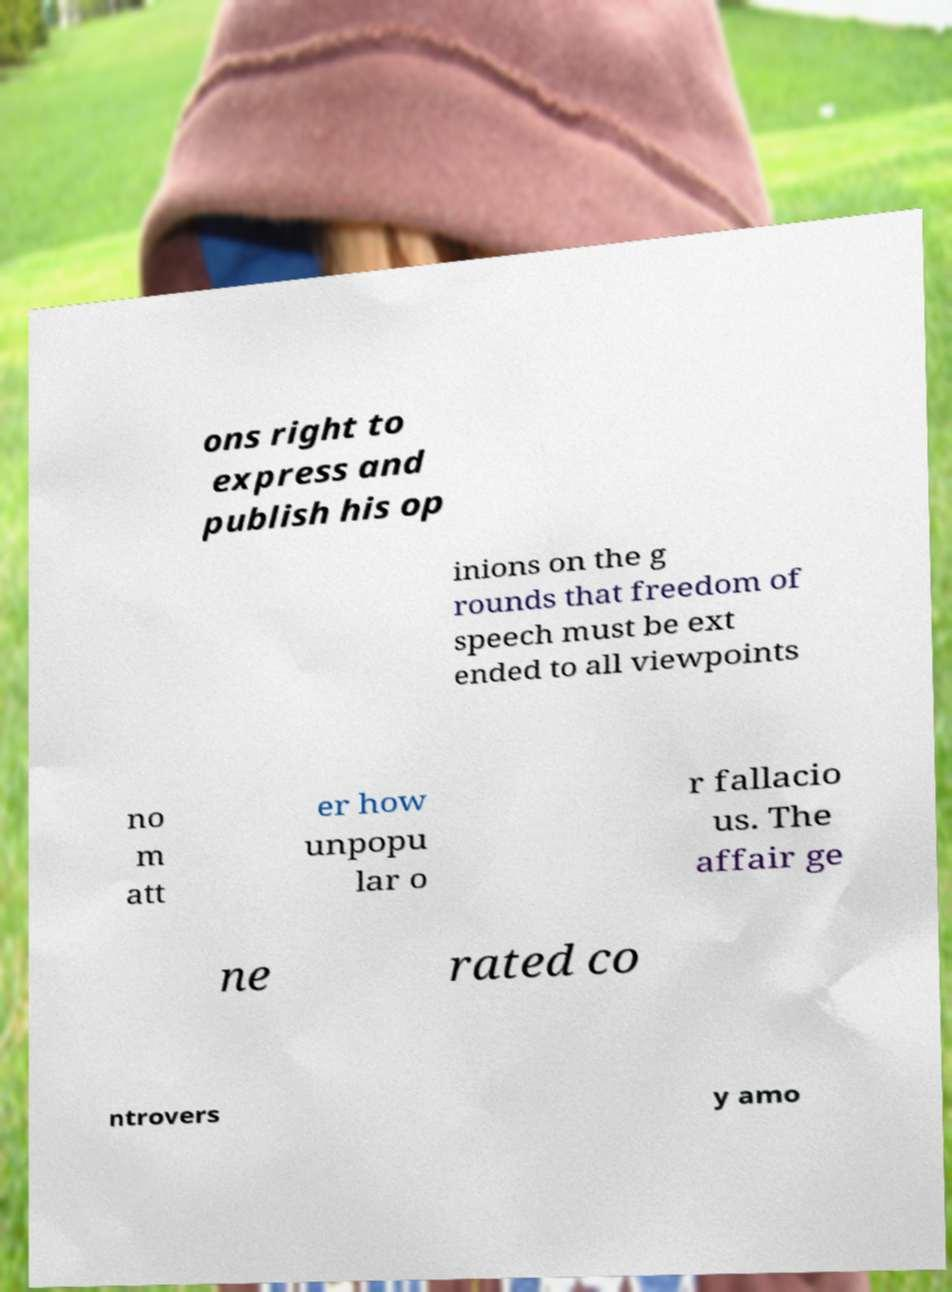Can you accurately transcribe the text from the provided image for me? ons right to express and publish his op inions on the g rounds that freedom of speech must be ext ended to all viewpoints no m att er how unpopu lar o r fallacio us. The affair ge ne rated co ntrovers y amo 